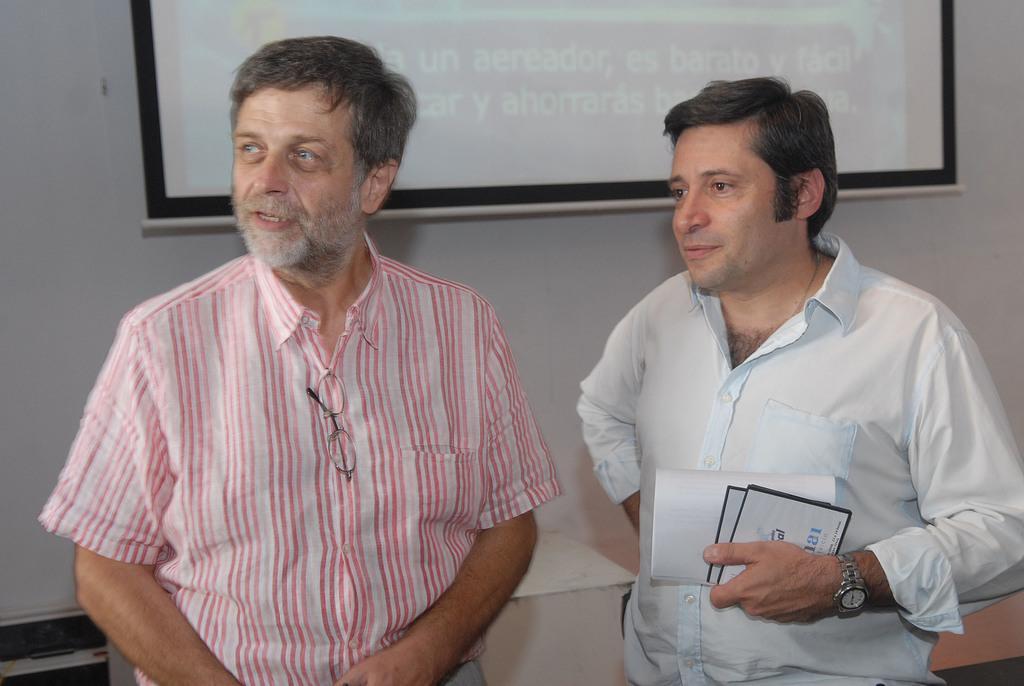How would you summarize this image in a sentence or two? On the left side of the image there is a man with pink and white shirt is standing and there are spectacles to his shirt. Beside him there is another man with shirt is standing and to his hand there is a watch and also he is holding few papers in his hand. Behind them there is a wall with screen. 